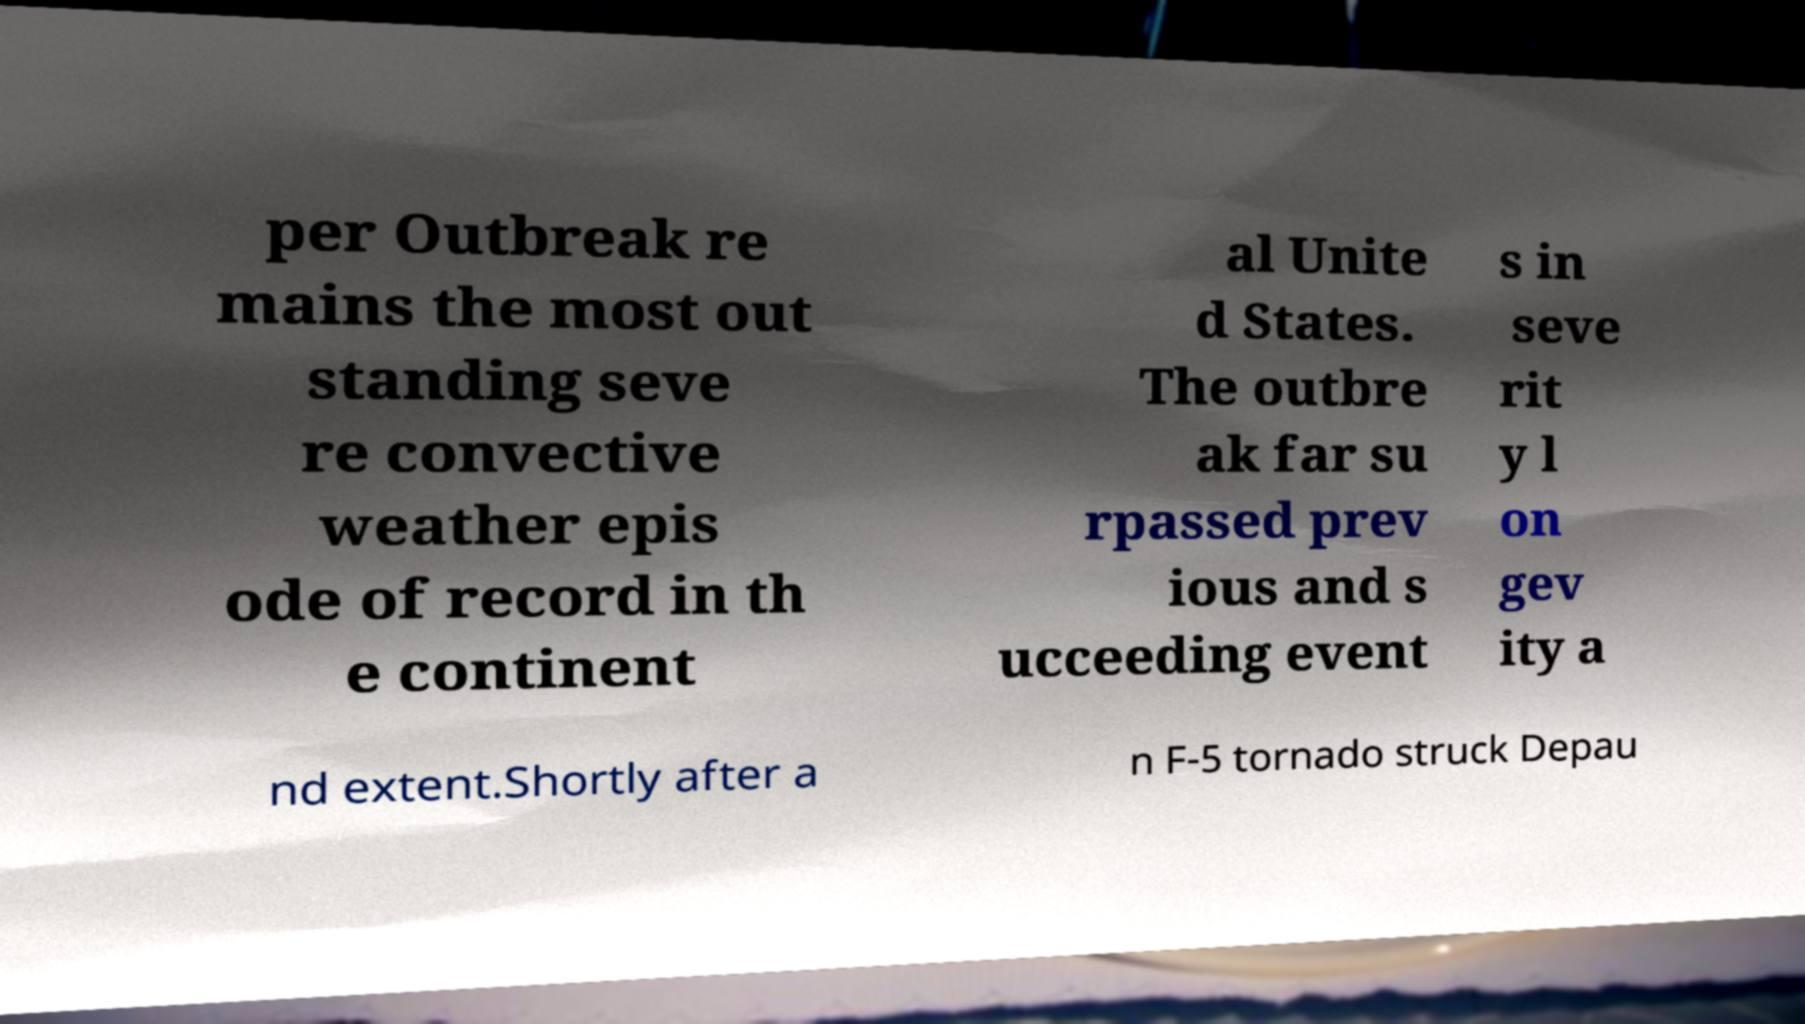There's text embedded in this image that I need extracted. Can you transcribe it verbatim? per Outbreak re mains the most out standing seve re convective weather epis ode of record in th e continent al Unite d States. The outbre ak far su rpassed prev ious and s ucceeding event s in seve rit y l on gev ity a nd extent.Shortly after a n F-5 tornado struck Depau 